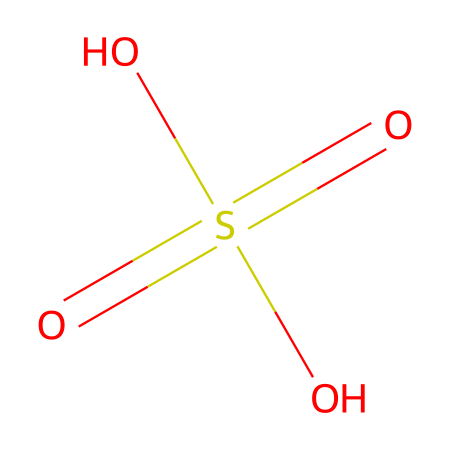What is the chemical name of the compound represented by this structure? The SMILES representation corresponds to a well-known compound used in industries, specifically sulfuric acid.
Answer: sulfuric acid How many oxygen atoms are present in this molecule? By examining the SMILES, we can identify there are four oxygen atoms connected to the sulfur atom.
Answer: four What is the central atom in this chemical structure? The SMILES indicates that the sulfur atom (S) is the central atom around which the oxygen atoms are arranged.
Answer: sulfur How many double bonds are there in this molecule? The structure shows that the sulfur atom has two double-bonded oxygen atoms which can be identified from the symbols in the SMILES notation.
Answer: two What type of acid is sulfuric acid classified as? Based on its composition and properties (containing sulfur and being a strong acid), sulfuric acid is classified as a mineral acid.
Answer: mineral acid What functional groups does sulfuric acid contain? The presence of -SO4 in the structure indicates that sulfuric acid contains sulfate functional groups, which are critical to its chemical identity.
Answer: sulfate What is the overall charge of sulfuric acid in solution? In aqueous solution, sulfuric acid is a strong acid that dissociates completely, resulting in positive hydrogen ions and negatively charged sulfate ions, leading to a neutral overall charge.
Answer: neutral 